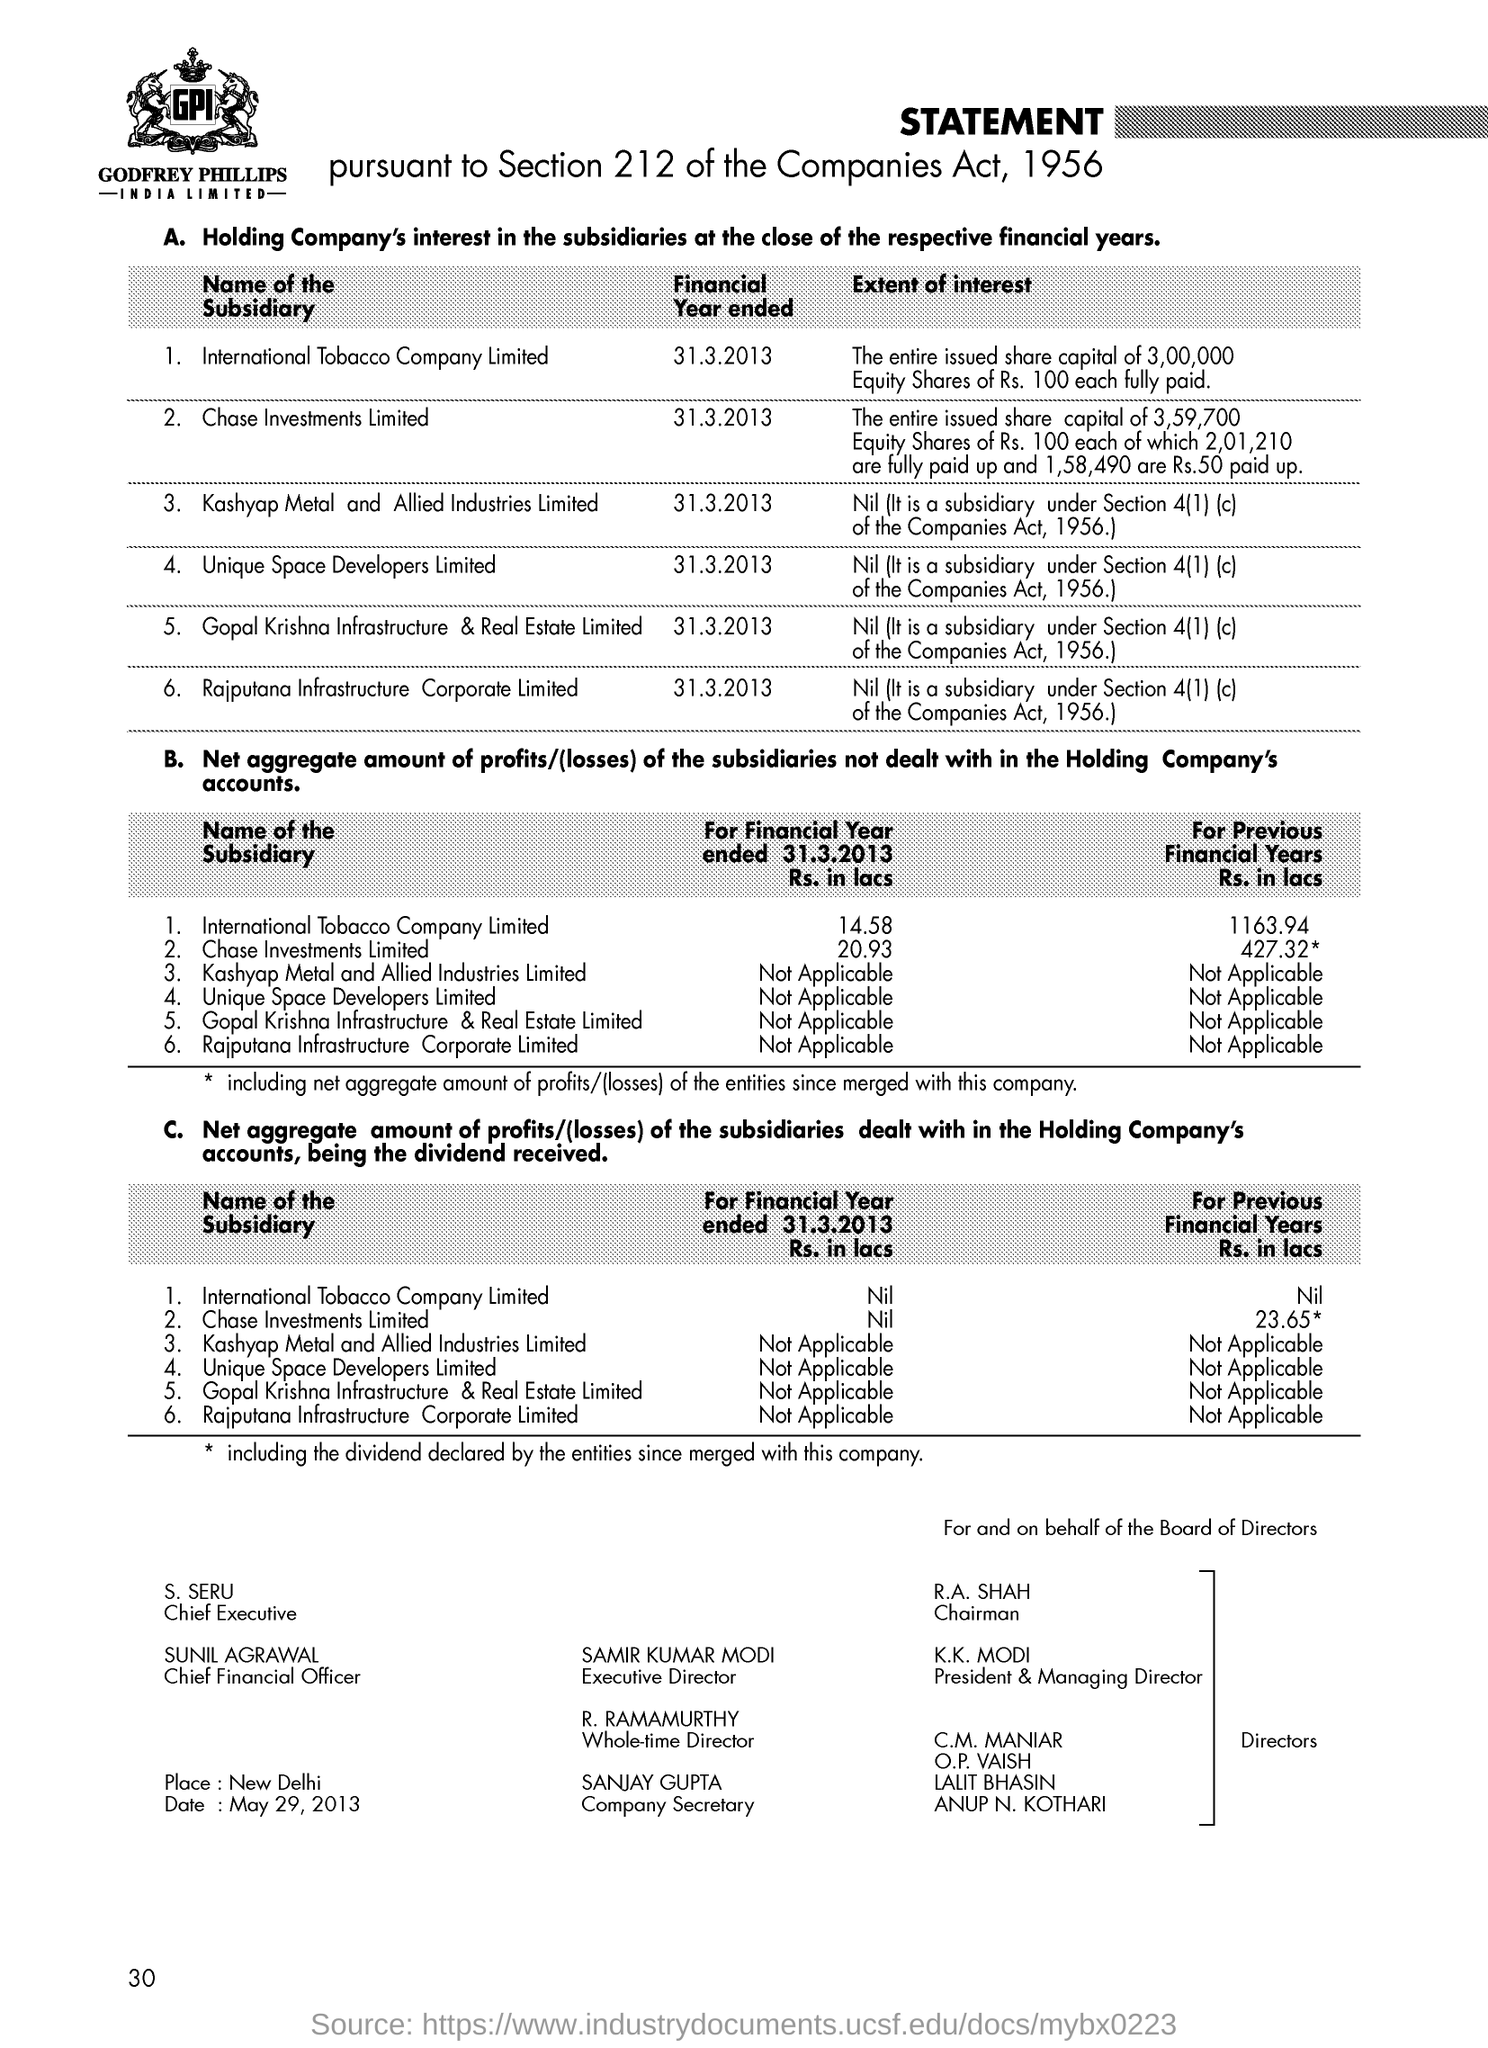Draw attention to some important aspects in this diagram. Godfrey Phillips India Limited is the name of the company. Mr. S. SERU is the Chief Executive of a person or organization. 